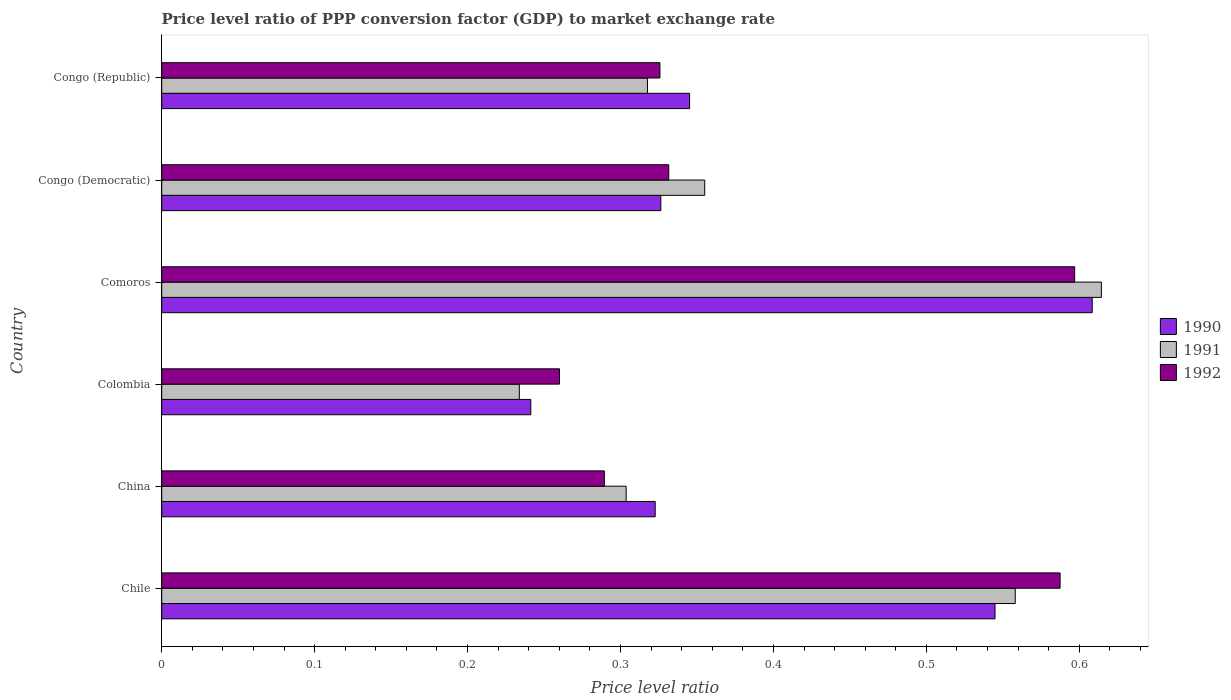Are the number of bars per tick equal to the number of legend labels?
Ensure brevity in your answer.  Yes. Are the number of bars on each tick of the Y-axis equal?
Your answer should be compact. Yes. What is the label of the 5th group of bars from the top?
Your answer should be very brief. China. What is the price level ratio in 1990 in Comoros?
Your answer should be very brief. 0.61. Across all countries, what is the maximum price level ratio in 1991?
Keep it short and to the point. 0.61. Across all countries, what is the minimum price level ratio in 1991?
Keep it short and to the point. 0.23. In which country was the price level ratio in 1991 maximum?
Your response must be concise. Comoros. In which country was the price level ratio in 1992 minimum?
Ensure brevity in your answer.  Colombia. What is the total price level ratio in 1991 in the graph?
Provide a short and direct response. 2.38. What is the difference between the price level ratio in 1991 in Chile and that in Colombia?
Offer a terse response. 0.32. What is the difference between the price level ratio in 1991 in Chile and the price level ratio in 1990 in Colombia?
Your answer should be compact. 0.32. What is the average price level ratio in 1992 per country?
Your answer should be very brief. 0.4. What is the difference between the price level ratio in 1992 and price level ratio in 1990 in Congo (Democratic)?
Your response must be concise. 0.01. In how many countries, is the price level ratio in 1991 greater than 0.18 ?
Provide a short and direct response. 6. What is the ratio of the price level ratio in 1990 in Chile to that in Congo (Republic)?
Ensure brevity in your answer.  1.58. Is the price level ratio in 1990 in Colombia less than that in Congo (Republic)?
Keep it short and to the point. Yes. Is the difference between the price level ratio in 1992 in Congo (Democratic) and Congo (Republic) greater than the difference between the price level ratio in 1990 in Congo (Democratic) and Congo (Republic)?
Give a very brief answer. Yes. What is the difference between the highest and the second highest price level ratio in 1991?
Provide a short and direct response. 0.06. What is the difference between the highest and the lowest price level ratio in 1991?
Your response must be concise. 0.38. Is the sum of the price level ratio in 1990 in China and Colombia greater than the maximum price level ratio in 1991 across all countries?
Provide a succinct answer. No. What does the 2nd bar from the bottom in China represents?
Provide a short and direct response. 1991. How many bars are there?
Make the answer very short. 18. How many countries are there in the graph?
Your answer should be very brief. 6. Does the graph contain grids?
Offer a very short reply. No. Where does the legend appear in the graph?
Make the answer very short. Center right. How are the legend labels stacked?
Give a very brief answer. Vertical. What is the title of the graph?
Provide a succinct answer. Price level ratio of PPP conversion factor (GDP) to market exchange rate. Does "2005" appear as one of the legend labels in the graph?
Your answer should be compact. No. What is the label or title of the X-axis?
Your answer should be very brief. Price level ratio. What is the label or title of the Y-axis?
Offer a very short reply. Country. What is the Price level ratio of 1990 in Chile?
Provide a short and direct response. 0.54. What is the Price level ratio of 1991 in Chile?
Ensure brevity in your answer.  0.56. What is the Price level ratio of 1992 in Chile?
Give a very brief answer. 0.59. What is the Price level ratio of 1990 in China?
Your response must be concise. 0.32. What is the Price level ratio of 1991 in China?
Ensure brevity in your answer.  0.3. What is the Price level ratio in 1992 in China?
Your answer should be compact. 0.29. What is the Price level ratio of 1990 in Colombia?
Offer a terse response. 0.24. What is the Price level ratio of 1991 in Colombia?
Provide a short and direct response. 0.23. What is the Price level ratio of 1992 in Colombia?
Offer a terse response. 0.26. What is the Price level ratio of 1990 in Comoros?
Provide a succinct answer. 0.61. What is the Price level ratio in 1991 in Comoros?
Give a very brief answer. 0.61. What is the Price level ratio in 1992 in Comoros?
Offer a very short reply. 0.6. What is the Price level ratio in 1990 in Congo (Democratic)?
Provide a short and direct response. 0.33. What is the Price level ratio in 1991 in Congo (Democratic)?
Your answer should be very brief. 0.36. What is the Price level ratio in 1992 in Congo (Democratic)?
Make the answer very short. 0.33. What is the Price level ratio of 1990 in Congo (Republic)?
Your response must be concise. 0.35. What is the Price level ratio of 1991 in Congo (Republic)?
Your answer should be very brief. 0.32. What is the Price level ratio in 1992 in Congo (Republic)?
Provide a succinct answer. 0.33. Across all countries, what is the maximum Price level ratio of 1990?
Provide a succinct answer. 0.61. Across all countries, what is the maximum Price level ratio in 1991?
Your answer should be very brief. 0.61. Across all countries, what is the maximum Price level ratio of 1992?
Give a very brief answer. 0.6. Across all countries, what is the minimum Price level ratio of 1990?
Provide a succinct answer. 0.24. Across all countries, what is the minimum Price level ratio in 1991?
Offer a terse response. 0.23. Across all countries, what is the minimum Price level ratio in 1992?
Provide a short and direct response. 0.26. What is the total Price level ratio of 1990 in the graph?
Give a very brief answer. 2.39. What is the total Price level ratio in 1991 in the graph?
Provide a succinct answer. 2.38. What is the total Price level ratio in 1992 in the graph?
Your response must be concise. 2.39. What is the difference between the Price level ratio of 1990 in Chile and that in China?
Provide a short and direct response. 0.22. What is the difference between the Price level ratio of 1991 in Chile and that in China?
Give a very brief answer. 0.25. What is the difference between the Price level ratio of 1992 in Chile and that in China?
Offer a very short reply. 0.3. What is the difference between the Price level ratio of 1990 in Chile and that in Colombia?
Give a very brief answer. 0.3. What is the difference between the Price level ratio of 1991 in Chile and that in Colombia?
Make the answer very short. 0.32. What is the difference between the Price level ratio of 1992 in Chile and that in Colombia?
Provide a short and direct response. 0.33. What is the difference between the Price level ratio in 1990 in Chile and that in Comoros?
Your answer should be very brief. -0.06. What is the difference between the Price level ratio in 1991 in Chile and that in Comoros?
Offer a terse response. -0.06. What is the difference between the Price level ratio of 1992 in Chile and that in Comoros?
Offer a very short reply. -0.01. What is the difference between the Price level ratio in 1990 in Chile and that in Congo (Democratic)?
Your response must be concise. 0.22. What is the difference between the Price level ratio of 1991 in Chile and that in Congo (Democratic)?
Ensure brevity in your answer.  0.2. What is the difference between the Price level ratio of 1992 in Chile and that in Congo (Democratic)?
Give a very brief answer. 0.26. What is the difference between the Price level ratio in 1990 in Chile and that in Congo (Republic)?
Your answer should be very brief. 0.2. What is the difference between the Price level ratio of 1991 in Chile and that in Congo (Republic)?
Ensure brevity in your answer.  0.24. What is the difference between the Price level ratio in 1992 in Chile and that in Congo (Republic)?
Give a very brief answer. 0.26. What is the difference between the Price level ratio in 1990 in China and that in Colombia?
Provide a succinct answer. 0.08. What is the difference between the Price level ratio of 1991 in China and that in Colombia?
Give a very brief answer. 0.07. What is the difference between the Price level ratio in 1992 in China and that in Colombia?
Offer a very short reply. 0.03. What is the difference between the Price level ratio in 1990 in China and that in Comoros?
Your answer should be very brief. -0.29. What is the difference between the Price level ratio of 1991 in China and that in Comoros?
Keep it short and to the point. -0.31. What is the difference between the Price level ratio of 1992 in China and that in Comoros?
Provide a succinct answer. -0.31. What is the difference between the Price level ratio of 1990 in China and that in Congo (Democratic)?
Provide a succinct answer. -0. What is the difference between the Price level ratio of 1991 in China and that in Congo (Democratic)?
Ensure brevity in your answer.  -0.05. What is the difference between the Price level ratio in 1992 in China and that in Congo (Democratic)?
Your response must be concise. -0.04. What is the difference between the Price level ratio of 1990 in China and that in Congo (Republic)?
Provide a succinct answer. -0.02. What is the difference between the Price level ratio of 1991 in China and that in Congo (Republic)?
Make the answer very short. -0.01. What is the difference between the Price level ratio in 1992 in China and that in Congo (Republic)?
Your answer should be compact. -0.04. What is the difference between the Price level ratio in 1990 in Colombia and that in Comoros?
Provide a succinct answer. -0.37. What is the difference between the Price level ratio of 1991 in Colombia and that in Comoros?
Offer a terse response. -0.38. What is the difference between the Price level ratio in 1992 in Colombia and that in Comoros?
Provide a succinct answer. -0.34. What is the difference between the Price level ratio in 1990 in Colombia and that in Congo (Democratic)?
Your answer should be compact. -0.09. What is the difference between the Price level ratio of 1991 in Colombia and that in Congo (Democratic)?
Offer a very short reply. -0.12. What is the difference between the Price level ratio of 1992 in Colombia and that in Congo (Democratic)?
Your response must be concise. -0.07. What is the difference between the Price level ratio in 1990 in Colombia and that in Congo (Republic)?
Your response must be concise. -0.1. What is the difference between the Price level ratio of 1991 in Colombia and that in Congo (Republic)?
Ensure brevity in your answer.  -0.08. What is the difference between the Price level ratio in 1992 in Colombia and that in Congo (Republic)?
Provide a succinct answer. -0.07. What is the difference between the Price level ratio of 1990 in Comoros and that in Congo (Democratic)?
Give a very brief answer. 0.28. What is the difference between the Price level ratio in 1991 in Comoros and that in Congo (Democratic)?
Your response must be concise. 0.26. What is the difference between the Price level ratio of 1992 in Comoros and that in Congo (Democratic)?
Your answer should be compact. 0.27. What is the difference between the Price level ratio of 1990 in Comoros and that in Congo (Republic)?
Provide a short and direct response. 0.26. What is the difference between the Price level ratio of 1991 in Comoros and that in Congo (Republic)?
Your response must be concise. 0.3. What is the difference between the Price level ratio in 1992 in Comoros and that in Congo (Republic)?
Your response must be concise. 0.27. What is the difference between the Price level ratio in 1990 in Congo (Democratic) and that in Congo (Republic)?
Ensure brevity in your answer.  -0.02. What is the difference between the Price level ratio of 1991 in Congo (Democratic) and that in Congo (Republic)?
Give a very brief answer. 0.04. What is the difference between the Price level ratio in 1992 in Congo (Democratic) and that in Congo (Republic)?
Provide a short and direct response. 0.01. What is the difference between the Price level ratio in 1990 in Chile and the Price level ratio in 1991 in China?
Give a very brief answer. 0.24. What is the difference between the Price level ratio in 1990 in Chile and the Price level ratio in 1992 in China?
Offer a very short reply. 0.26. What is the difference between the Price level ratio in 1991 in Chile and the Price level ratio in 1992 in China?
Give a very brief answer. 0.27. What is the difference between the Price level ratio of 1990 in Chile and the Price level ratio of 1991 in Colombia?
Give a very brief answer. 0.31. What is the difference between the Price level ratio of 1990 in Chile and the Price level ratio of 1992 in Colombia?
Ensure brevity in your answer.  0.28. What is the difference between the Price level ratio in 1991 in Chile and the Price level ratio in 1992 in Colombia?
Your response must be concise. 0.3. What is the difference between the Price level ratio of 1990 in Chile and the Price level ratio of 1991 in Comoros?
Your response must be concise. -0.07. What is the difference between the Price level ratio of 1990 in Chile and the Price level ratio of 1992 in Comoros?
Make the answer very short. -0.05. What is the difference between the Price level ratio of 1991 in Chile and the Price level ratio of 1992 in Comoros?
Give a very brief answer. -0.04. What is the difference between the Price level ratio of 1990 in Chile and the Price level ratio of 1991 in Congo (Democratic)?
Give a very brief answer. 0.19. What is the difference between the Price level ratio in 1990 in Chile and the Price level ratio in 1992 in Congo (Democratic)?
Give a very brief answer. 0.21. What is the difference between the Price level ratio in 1991 in Chile and the Price level ratio in 1992 in Congo (Democratic)?
Ensure brevity in your answer.  0.23. What is the difference between the Price level ratio of 1990 in Chile and the Price level ratio of 1991 in Congo (Republic)?
Offer a very short reply. 0.23. What is the difference between the Price level ratio in 1990 in Chile and the Price level ratio in 1992 in Congo (Republic)?
Provide a short and direct response. 0.22. What is the difference between the Price level ratio of 1991 in Chile and the Price level ratio of 1992 in Congo (Republic)?
Give a very brief answer. 0.23. What is the difference between the Price level ratio of 1990 in China and the Price level ratio of 1991 in Colombia?
Provide a short and direct response. 0.09. What is the difference between the Price level ratio in 1990 in China and the Price level ratio in 1992 in Colombia?
Offer a terse response. 0.06. What is the difference between the Price level ratio in 1991 in China and the Price level ratio in 1992 in Colombia?
Ensure brevity in your answer.  0.04. What is the difference between the Price level ratio of 1990 in China and the Price level ratio of 1991 in Comoros?
Provide a short and direct response. -0.29. What is the difference between the Price level ratio in 1990 in China and the Price level ratio in 1992 in Comoros?
Provide a short and direct response. -0.27. What is the difference between the Price level ratio of 1991 in China and the Price level ratio of 1992 in Comoros?
Your response must be concise. -0.29. What is the difference between the Price level ratio of 1990 in China and the Price level ratio of 1991 in Congo (Democratic)?
Provide a succinct answer. -0.03. What is the difference between the Price level ratio in 1990 in China and the Price level ratio in 1992 in Congo (Democratic)?
Your answer should be very brief. -0.01. What is the difference between the Price level ratio of 1991 in China and the Price level ratio of 1992 in Congo (Democratic)?
Provide a succinct answer. -0.03. What is the difference between the Price level ratio of 1990 in China and the Price level ratio of 1991 in Congo (Republic)?
Make the answer very short. 0.01. What is the difference between the Price level ratio of 1990 in China and the Price level ratio of 1992 in Congo (Republic)?
Keep it short and to the point. -0. What is the difference between the Price level ratio in 1991 in China and the Price level ratio in 1992 in Congo (Republic)?
Your answer should be very brief. -0.02. What is the difference between the Price level ratio of 1990 in Colombia and the Price level ratio of 1991 in Comoros?
Provide a succinct answer. -0.37. What is the difference between the Price level ratio of 1990 in Colombia and the Price level ratio of 1992 in Comoros?
Offer a terse response. -0.36. What is the difference between the Price level ratio in 1991 in Colombia and the Price level ratio in 1992 in Comoros?
Provide a short and direct response. -0.36. What is the difference between the Price level ratio of 1990 in Colombia and the Price level ratio of 1991 in Congo (Democratic)?
Your response must be concise. -0.11. What is the difference between the Price level ratio of 1990 in Colombia and the Price level ratio of 1992 in Congo (Democratic)?
Provide a short and direct response. -0.09. What is the difference between the Price level ratio of 1991 in Colombia and the Price level ratio of 1992 in Congo (Democratic)?
Your answer should be very brief. -0.1. What is the difference between the Price level ratio of 1990 in Colombia and the Price level ratio of 1991 in Congo (Republic)?
Your answer should be compact. -0.08. What is the difference between the Price level ratio of 1990 in Colombia and the Price level ratio of 1992 in Congo (Republic)?
Make the answer very short. -0.08. What is the difference between the Price level ratio in 1991 in Colombia and the Price level ratio in 1992 in Congo (Republic)?
Offer a terse response. -0.09. What is the difference between the Price level ratio in 1990 in Comoros and the Price level ratio in 1991 in Congo (Democratic)?
Provide a succinct answer. 0.25. What is the difference between the Price level ratio of 1990 in Comoros and the Price level ratio of 1992 in Congo (Democratic)?
Give a very brief answer. 0.28. What is the difference between the Price level ratio in 1991 in Comoros and the Price level ratio in 1992 in Congo (Democratic)?
Offer a terse response. 0.28. What is the difference between the Price level ratio in 1990 in Comoros and the Price level ratio in 1991 in Congo (Republic)?
Make the answer very short. 0.29. What is the difference between the Price level ratio in 1990 in Comoros and the Price level ratio in 1992 in Congo (Republic)?
Your response must be concise. 0.28. What is the difference between the Price level ratio in 1991 in Comoros and the Price level ratio in 1992 in Congo (Republic)?
Ensure brevity in your answer.  0.29. What is the difference between the Price level ratio in 1990 in Congo (Democratic) and the Price level ratio in 1991 in Congo (Republic)?
Offer a very short reply. 0.01. What is the difference between the Price level ratio in 1990 in Congo (Democratic) and the Price level ratio in 1992 in Congo (Republic)?
Your answer should be very brief. 0. What is the difference between the Price level ratio of 1991 in Congo (Democratic) and the Price level ratio of 1992 in Congo (Republic)?
Offer a very short reply. 0.03. What is the average Price level ratio of 1990 per country?
Your answer should be compact. 0.4. What is the average Price level ratio of 1991 per country?
Offer a very short reply. 0.4. What is the average Price level ratio in 1992 per country?
Give a very brief answer. 0.4. What is the difference between the Price level ratio in 1990 and Price level ratio in 1991 in Chile?
Your answer should be very brief. -0.01. What is the difference between the Price level ratio of 1990 and Price level ratio of 1992 in Chile?
Provide a short and direct response. -0.04. What is the difference between the Price level ratio of 1991 and Price level ratio of 1992 in Chile?
Make the answer very short. -0.03. What is the difference between the Price level ratio of 1990 and Price level ratio of 1991 in China?
Provide a succinct answer. 0.02. What is the difference between the Price level ratio in 1990 and Price level ratio in 1992 in China?
Make the answer very short. 0.03. What is the difference between the Price level ratio in 1991 and Price level ratio in 1992 in China?
Your answer should be compact. 0.01. What is the difference between the Price level ratio in 1990 and Price level ratio in 1991 in Colombia?
Give a very brief answer. 0.01. What is the difference between the Price level ratio of 1990 and Price level ratio of 1992 in Colombia?
Your response must be concise. -0.02. What is the difference between the Price level ratio of 1991 and Price level ratio of 1992 in Colombia?
Keep it short and to the point. -0.03. What is the difference between the Price level ratio of 1990 and Price level ratio of 1991 in Comoros?
Provide a succinct answer. -0.01. What is the difference between the Price level ratio of 1990 and Price level ratio of 1992 in Comoros?
Make the answer very short. 0.01. What is the difference between the Price level ratio in 1991 and Price level ratio in 1992 in Comoros?
Keep it short and to the point. 0.02. What is the difference between the Price level ratio in 1990 and Price level ratio in 1991 in Congo (Democratic)?
Make the answer very short. -0.03. What is the difference between the Price level ratio of 1990 and Price level ratio of 1992 in Congo (Democratic)?
Provide a short and direct response. -0.01. What is the difference between the Price level ratio of 1991 and Price level ratio of 1992 in Congo (Democratic)?
Your answer should be very brief. 0.02. What is the difference between the Price level ratio of 1990 and Price level ratio of 1991 in Congo (Republic)?
Keep it short and to the point. 0.03. What is the difference between the Price level ratio of 1990 and Price level ratio of 1992 in Congo (Republic)?
Provide a succinct answer. 0.02. What is the difference between the Price level ratio in 1991 and Price level ratio in 1992 in Congo (Republic)?
Make the answer very short. -0.01. What is the ratio of the Price level ratio of 1990 in Chile to that in China?
Your answer should be compact. 1.69. What is the ratio of the Price level ratio of 1991 in Chile to that in China?
Your response must be concise. 1.84. What is the ratio of the Price level ratio of 1992 in Chile to that in China?
Ensure brevity in your answer.  2.03. What is the ratio of the Price level ratio of 1990 in Chile to that in Colombia?
Keep it short and to the point. 2.26. What is the ratio of the Price level ratio in 1991 in Chile to that in Colombia?
Your answer should be compact. 2.39. What is the ratio of the Price level ratio in 1992 in Chile to that in Colombia?
Provide a succinct answer. 2.26. What is the ratio of the Price level ratio in 1990 in Chile to that in Comoros?
Offer a very short reply. 0.9. What is the ratio of the Price level ratio in 1991 in Chile to that in Comoros?
Provide a succinct answer. 0.91. What is the ratio of the Price level ratio in 1990 in Chile to that in Congo (Democratic)?
Ensure brevity in your answer.  1.67. What is the ratio of the Price level ratio of 1991 in Chile to that in Congo (Democratic)?
Provide a succinct answer. 1.57. What is the ratio of the Price level ratio of 1992 in Chile to that in Congo (Democratic)?
Offer a terse response. 1.77. What is the ratio of the Price level ratio in 1990 in Chile to that in Congo (Republic)?
Give a very brief answer. 1.58. What is the ratio of the Price level ratio in 1991 in Chile to that in Congo (Republic)?
Offer a terse response. 1.76. What is the ratio of the Price level ratio in 1992 in Chile to that in Congo (Republic)?
Provide a short and direct response. 1.8. What is the ratio of the Price level ratio of 1990 in China to that in Colombia?
Ensure brevity in your answer.  1.34. What is the ratio of the Price level ratio in 1991 in China to that in Colombia?
Your answer should be very brief. 1.3. What is the ratio of the Price level ratio of 1992 in China to that in Colombia?
Provide a short and direct response. 1.11. What is the ratio of the Price level ratio in 1990 in China to that in Comoros?
Your response must be concise. 0.53. What is the ratio of the Price level ratio in 1991 in China to that in Comoros?
Provide a succinct answer. 0.49. What is the ratio of the Price level ratio in 1992 in China to that in Comoros?
Offer a very short reply. 0.48. What is the ratio of the Price level ratio in 1990 in China to that in Congo (Democratic)?
Give a very brief answer. 0.99. What is the ratio of the Price level ratio in 1991 in China to that in Congo (Democratic)?
Your answer should be very brief. 0.86. What is the ratio of the Price level ratio in 1992 in China to that in Congo (Democratic)?
Keep it short and to the point. 0.87. What is the ratio of the Price level ratio in 1990 in China to that in Congo (Republic)?
Make the answer very short. 0.93. What is the ratio of the Price level ratio in 1991 in China to that in Congo (Republic)?
Provide a short and direct response. 0.96. What is the ratio of the Price level ratio of 1992 in China to that in Congo (Republic)?
Provide a succinct answer. 0.89. What is the ratio of the Price level ratio of 1990 in Colombia to that in Comoros?
Offer a terse response. 0.4. What is the ratio of the Price level ratio of 1991 in Colombia to that in Comoros?
Keep it short and to the point. 0.38. What is the ratio of the Price level ratio in 1992 in Colombia to that in Comoros?
Ensure brevity in your answer.  0.44. What is the ratio of the Price level ratio of 1990 in Colombia to that in Congo (Democratic)?
Ensure brevity in your answer.  0.74. What is the ratio of the Price level ratio in 1991 in Colombia to that in Congo (Democratic)?
Make the answer very short. 0.66. What is the ratio of the Price level ratio in 1992 in Colombia to that in Congo (Democratic)?
Provide a short and direct response. 0.78. What is the ratio of the Price level ratio of 1990 in Colombia to that in Congo (Republic)?
Offer a very short reply. 0.7. What is the ratio of the Price level ratio of 1991 in Colombia to that in Congo (Republic)?
Your response must be concise. 0.74. What is the ratio of the Price level ratio in 1992 in Colombia to that in Congo (Republic)?
Your response must be concise. 0.8. What is the ratio of the Price level ratio in 1990 in Comoros to that in Congo (Democratic)?
Provide a succinct answer. 1.86. What is the ratio of the Price level ratio of 1991 in Comoros to that in Congo (Democratic)?
Provide a short and direct response. 1.73. What is the ratio of the Price level ratio of 1992 in Comoros to that in Congo (Democratic)?
Give a very brief answer. 1.8. What is the ratio of the Price level ratio in 1990 in Comoros to that in Congo (Republic)?
Ensure brevity in your answer.  1.76. What is the ratio of the Price level ratio of 1991 in Comoros to that in Congo (Republic)?
Provide a succinct answer. 1.93. What is the ratio of the Price level ratio of 1992 in Comoros to that in Congo (Republic)?
Make the answer very short. 1.83. What is the ratio of the Price level ratio of 1990 in Congo (Democratic) to that in Congo (Republic)?
Offer a terse response. 0.95. What is the ratio of the Price level ratio in 1991 in Congo (Democratic) to that in Congo (Republic)?
Your response must be concise. 1.12. What is the ratio of the Price level ratio of 1992 in Congo (Democratic) to that in Congo (Republic)?
Offer a very short reply. 1.02. What is the difference between the highest and the second highest Price level ratio of 1990?
Offer a very short reply. 0.06. What is the difference between the highest and the second highest Price level ratio of 1991?
Your response must be concise. 0.06. What is the difference between the highest and the second highest Price level ratio in 1992?
Give a very brief answer. 0.01. What is the difference between the highest and the lowest Price level ratio of 1990?
Your answer should be compact. 0.37. What is the difference between the highest and the lowest Price level ratio in 1991?
Make the answer very short. 0.38. What is the difference between the highest and the lowest Price level ratio of 1992?
Give a very brief answer. 0.34. 